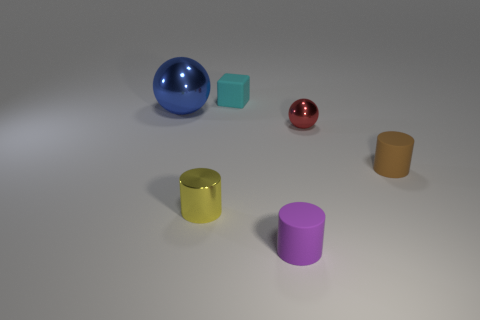The other metallic object that is the same shape as the tiny red object is what size?
Offer a very short reply. Large. There is a object that is both right of the blue object and behind the tiny red thing; what is its color?
Provide a succinct answer. Cyan. Is the material of the tiny purple cylinder the same as the sphere to the right of the tiny purple cylinder?
Offer a terse response. No. Are there fewer big objects that are in front of the purple thing than big gray cubes?
Your answer should be very brief. No. How many other things are there of the same shape as the tiny red shiny object?
Your response must be concise. 1. How many other objects are there of the same size as the brown cylinder?
Make the answer very short. 4. How many cubes are rubber things or tiny red shiny objects?
Your response must be concise. 1. Do the small metal thing that is in front of the small metallic sphere and the small cyan rubber thing have the same shape?
Ensure brevity in your answer.  No. Is the number of tiny objects that are in front of the tiny brown rubber object greater than the number of blue metal balls?
Give a very brief answer. Yes. What color is the sphere that is the same size as the cyan matte block?
Ensure brevity in your answer.  Red. 